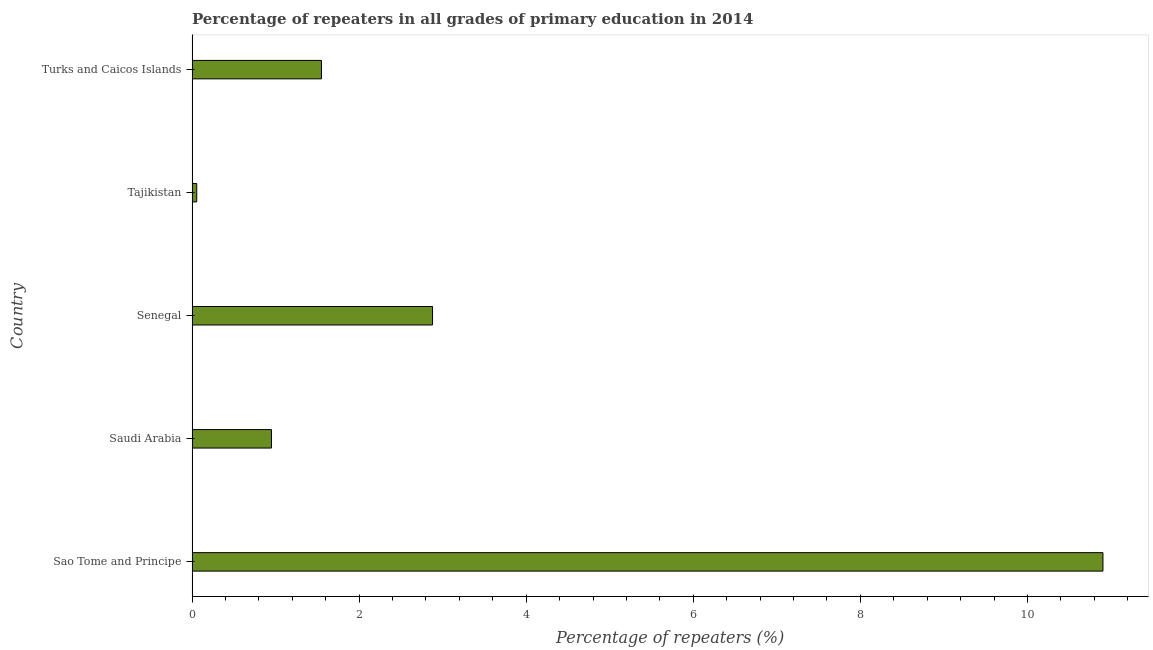Does the graph contain grids?
Provide a succinct answer. No. What is the title of the graph?
Your answer should be very brief. Percentage of repeaters in all grades of primary education in 2014. What is the label or title of the X-axis?
Offer a terse response. Percentage of repeaters (%). What is the percentage of repeaters in primary education in Tajikistan?
Your response must be concise. 0.06. Across all countries, what is the maximum percentage of repeaters in primary education?
Your answer should be compact. 10.9. Across all countries, what is the minimum percentage of repeaters in primary education?
Offer a very short reply. 0.06. In which country was the percentage of repeaters in primary education maximum?
Provide a succinct answer. Sao Tome and Principe. In which country was the percentage of repeaters in primary education minimum?
Provide a succinct answer. Tajikistan. What is the sum of the percentage of repeaters in primary education?
Ensure brevity in your answer.  16.34. What is the difference between the percentage of repeaters in primary education in Sao Tome and Principe and Turks and Caicos Islands?
Provide a succinct answer. 9.35. What is the average percentage of repeaters in primary education per country?
Provide a short and direct response. 3.27. What is the median percentage of repeaters in primary education?
Your answer should be very brief. 1.55. In how many countries, is the percentage of repeaters in primary education greater than 4.4 %?
Provide a succinct answer. 1. What is the ratio of the percentage of repeaters in primary education in Saudi Arabia to that in Tajikistan?
Your answer should be very brief. 16.97. Is the difference between the percentage of repeaters in primary education in Senegal and Tajikistan greater than the difference between any two countries?
Make the answer very short. No. What is the difference between the highest and the second highest percentage of repeaters in primary education?
Your answer should be very brief. 8.03. Is the sum of the percentage of repeaters in primary education in Sao Tome and Principe and Tajikistan greater than the maximum percentage of repeaters in primary education across all countries?
Offer a terse response. Yes. What is the difference between the highest and the lowest percentage of repeaters in primary education?
Offer a very short reply. 10.85. In how many countries, is the percentage of repeaters in primary education greater than the average percentage of repeaters in primary education taken over all countries?
Provide a short and direct response. 1. How many countries are there in the graph?
Ensure brevity in your answer.  5. What is the difference between two consecutive major ticks on the X-axis?
Your answer should be compact. 2. What is the Percentage of repeaters (%) of Sao Tome and Principe?
Your answer should be compact. 10.9. What is the Percentage of repeaters (%) in Saudi Arabia?
Provide a succinct answer. 0.95. What is the Percentage of repeaters (%) in Senegal?
Provide a short and direct response. 2.88. What is the Percentage of repeaters (%) of Tajikistan?
Make the answer very short. 0.06. What is the Percentage of repeaters (%) of Turks and Caicos Islands?
Your response must be concise. 1.55. What is the difference between the Percentage of repeaters (%) in Sao Tome and Principe and Saudi Arabia?
Provide a succinct answer. 9.95. What is the difference between the Percentage of repeaters (%) in Sao Tome and Principe and Senegal?
Keep it short and to the point. 8.02. What is the difference between the Percentage of repeaters (%) in Sao Tome and Principe and Tajikistan?
Give a very brief answer. 10.85. What is the difference between the Percentage of repeaters (%) in Sao Tome and Principe and Turks and Caicos Islands?
Provide a short and direct response. 9.35. What is the difference between the Percentage of repeaters (%) in Saudi Arabia and Senegal?
Give a very brief answer. -1.93. What is the difference between the Percentage of repeaters (%) in Saudi Arabia and Tajikistan?
Your answer should be very brief. 0.89. What is the difference between the Percentage of repeaters (%) in Saudi Arabia and Turks and Caicos Islands?
Offer a terse response. -0.6. What is the difference between the Percentage of repeaters (%) in Senegal and Tajikistan?
Make the answer very short. 2.82. What is the difference between the Percentage of repeaters (%) in Senegal and Turks and Caicos Islands?
Your response must be concise. 1.33. What is the difference between the Percentage of repeaters (%) in Tajikistan and Turks and Caicos Islands?
Ensure brevity in your answer.  -1.49. What is the ratio of the Percentage of repeaters (%) in Sao Tome and Principe to that in Saudi Arabia?
Your answer should be very brief. 11.47. What is the ratio of the Percentage of repeaters (%) in Sao Tome and Principe to that in Senegal?
Your answer should be compact. 3.79. What is the ratio of the Percentage of repeaters (%) in Sao Tome and Principe to that in Tajikistan?
Make the answer very short. 194.67. What is the ratio of the Percentage of repeaters (%) in Sao Tome and Principe to that in Turks and Caicos Islands?
Keep it short and to the point. 7.04. What is the ratio of the Percentage of repeaters (%) in Saudi Arabia to that in Senegal?
Offer a very short reply. 0.33. What is the ratio of the Percentage of repeaters (%) in Saudi Arabia to that in Tajikistan?
Your answer should be very brief. 16.97. What is the ratio of the Percentage of repeaters (%) in Saudi Arabia to that in Turks and Caicos Islands?
Offer a terse response. 0.61. What is the ratio of the Percentage of repeaters (%) in Senegal to that in Tajikistan?
Keep it short and to the point. 51.39. What is the ratio of the Percentage of repeaters (%) in Senegal to that in Turks and Caicos Islands?
Offer a very short reply. 1.86. What is the ratio of the Percentage of repeaters (%) in Tajikistan to that in Turks and Caicos Islands?
Give a very brief answer. 0.04. 